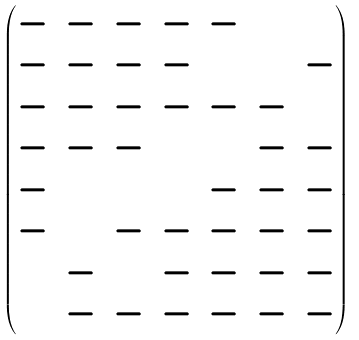<formula> <loc_0><loc_0><loc_500><loc_500>\begin{pmatrix} - & - & - & - & - & 2 & 3 \\ - & - & - & - & 4 & 1 & - \\ - & - & - & - & - & - & 1 \\ - & - & - & 5 & 2 & - & - \\ - & 6 & 7 & 4 & - & - & - \\ - & 5 & - & - & - & - & - \\ 8 & - & 5 & - & - & - & - \\ 7 & - & - & - & - & - & - \end{pmatrix}</formula> 